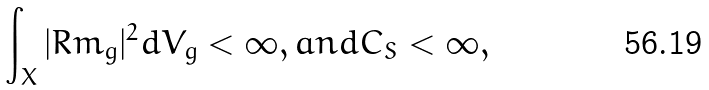<formula> <loc_0><loc_0><loc_500><loc_500>\int _ { X } | R m _ { g } | ^ { 2 } d V _ { g } < \infty , a n d C _ { S } < \infty ,</formula> 